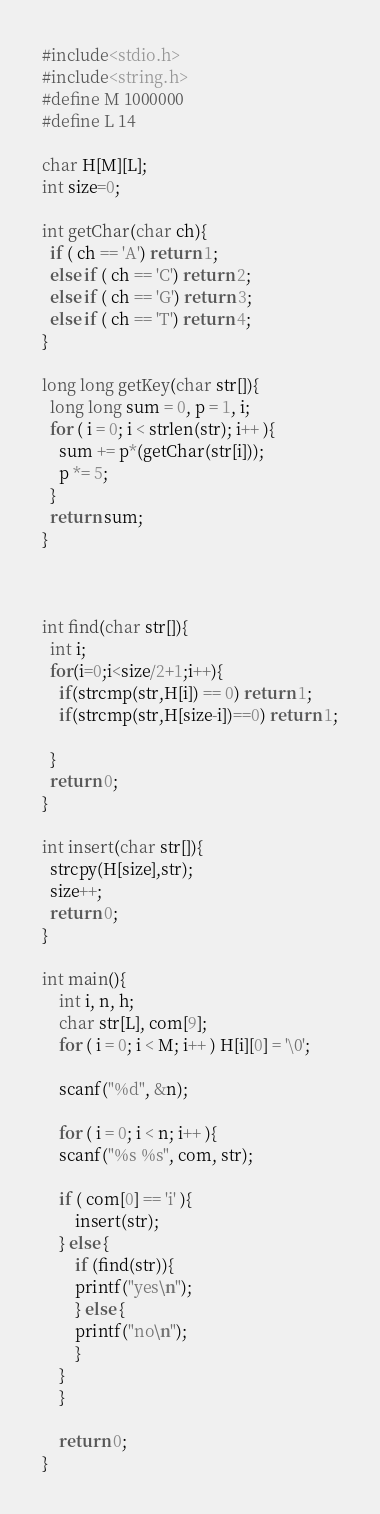<code> <loc_0><loc_0><loc_500><loc_500><_C_>#include<stdio.h>
#include<string.h>
#define M 1000000
#define L 14

char H[M][L];
int size=0;

int getChar(char ch){
  if ( ch == 'A') return 1;
  else if ( ch == 'C') return 2;
  else if ( ch == 'G') return 3;
  else if ( ch == 'T') return 4;
}

long long getKey(char str[]){
  long long sum = 0, p = 1, i;
  for ( i = 0; i < strlen(str); i++ ){
    sum += p*(getChar(str[i]));
    p *= 5;
  }
  return sum;
}



int find(char str[]){
  int i;
  for(i=0;i<size/2+1;i++){
    if(strcmp(str,H[i]) == 0) return 1;
    if(strcmp(str,H[size-i])==0) return 1;
    
  }
  return 0;
}

int insert(char str[]){
  strcpy(H[size],str);
  size++;
  return 0;
}

int main(){
    int i, n, h;
    char str[L], com[9];
    for ( i = 0; i < M; i++ ) H[i][0] = '\0';
    
    scanf("%d", &n);
    
    for ( i = 0; i < n; i++ ){
	scanf("%s %s", com, str);
	
	if ( com[0] == 'i' ){
	    insert(str);
	} else {
	    if (find(str)){
		printf("yes\n");
	    } else {
		printf("no\n");
	    }
	}
    }

    return 0;
}

</code> 